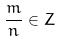Convert formula to latex. <formula><loc_0><loc_0><loc_500><loc_500>\frac { m } { n } \in Z</formula> 